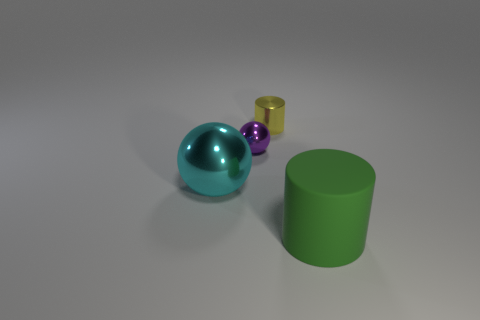Add 2 big green cylinders. How many objects exist? 6 Add 2 large spheres. How many large spheres are left? 3 Add 4 cyan shiny objects. How many cyan shiny objects exist? 5 Subtract 0 yellow blocks. How many objects are left? 4 Subtract all small metallic cylinders. Subtract all tiny objects. How many objects are left? 1 